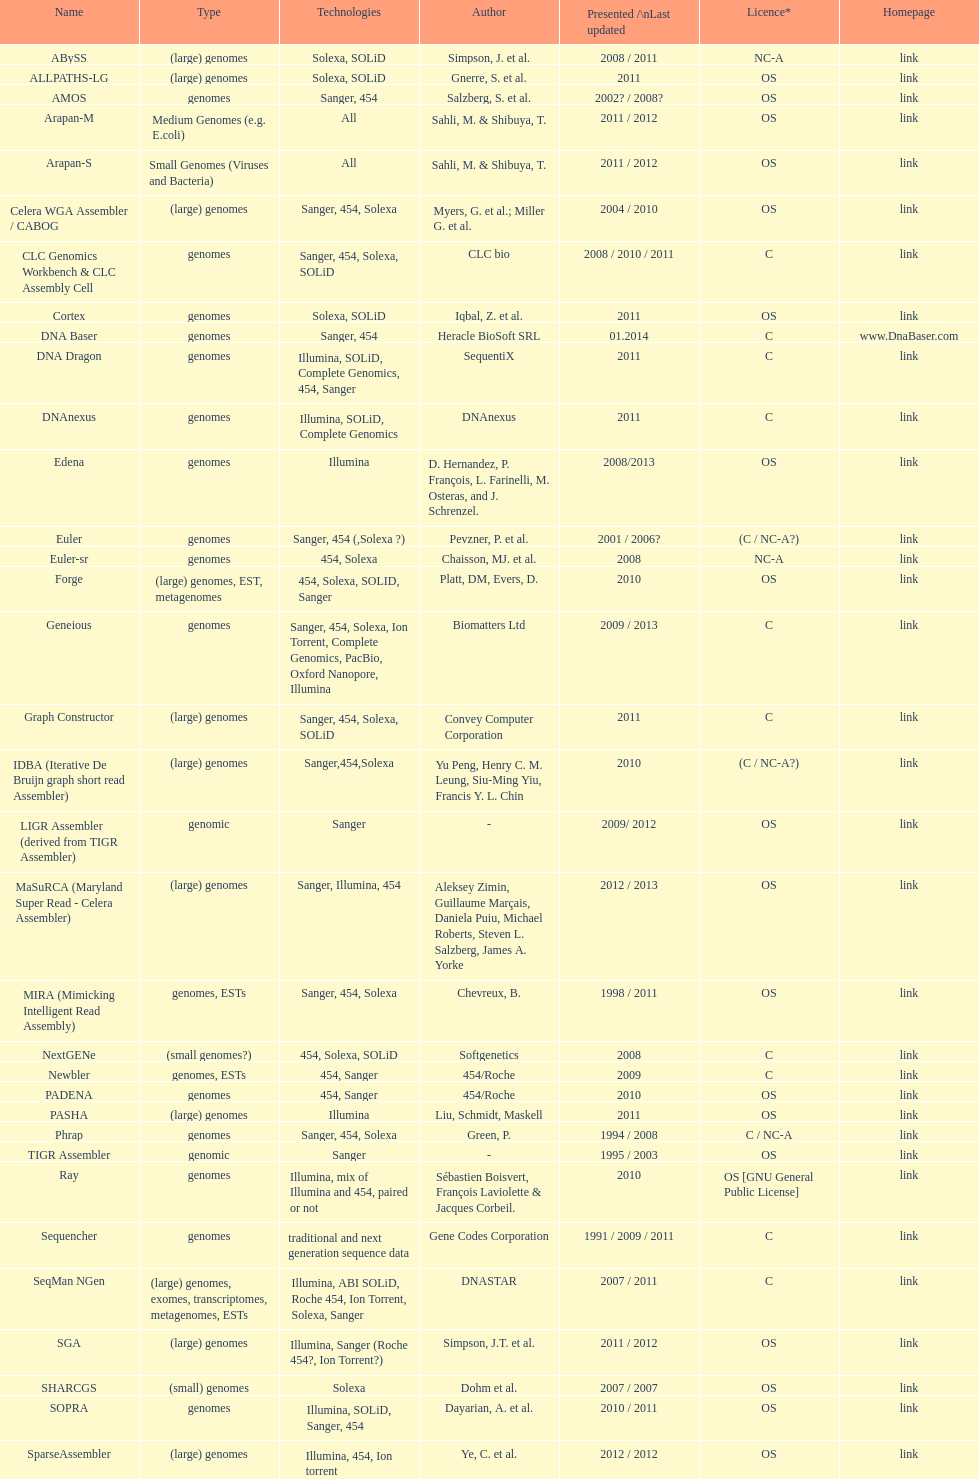Which license is listed more, os or c? OS. 